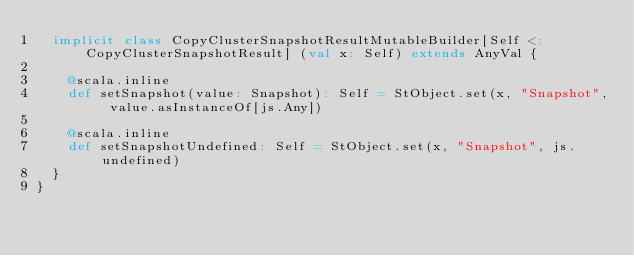Convert code to text. <code><loc_0><loc_0><loc_500><loc_500><_Scala_>  implicit class CopyClusterSnapshotResultMutableBuilder[Self <: CopyClusterSnapshotResult] (val x: Self) extends AnyVal {
    
    @scala.inline
    def setSnapshot(value: Snapshot): Self = StObject.set(x, "Snapshot", value.asInstanceOf[js.Any])
    
    @scala.inline
    def setSnapshotUndefined: Self = StObject.set(x, "Snapshot", js.undefined)
  }
}
</code> 